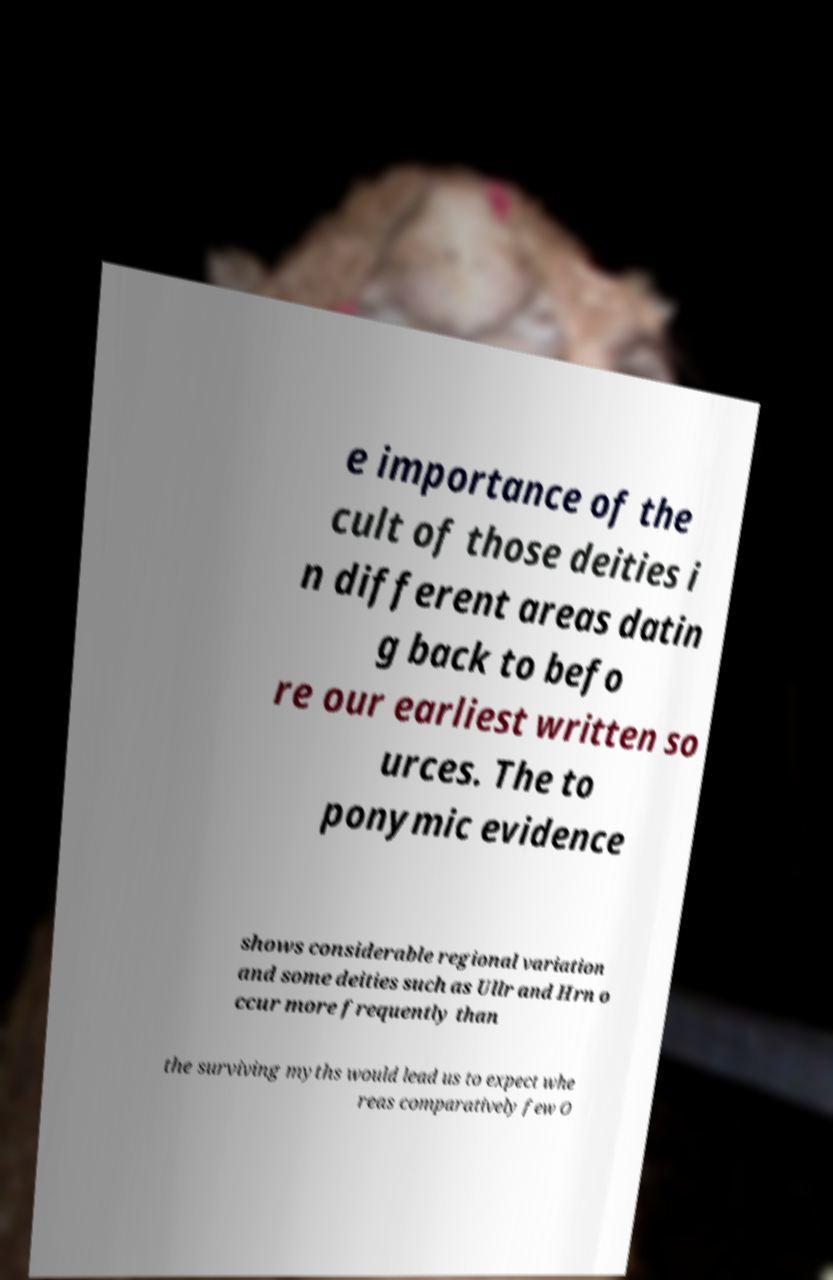Please identify and transcribe the text found in this image. e importance of the cult of those deities i n different areas datin g back to befo re our earliest written so urces. The to ponymic evidence shows considerable regional variation and some deities such as Ullr and Hrn o ccur more frequently than the surviving myths would lead us to expect whe reas comparatively few O 